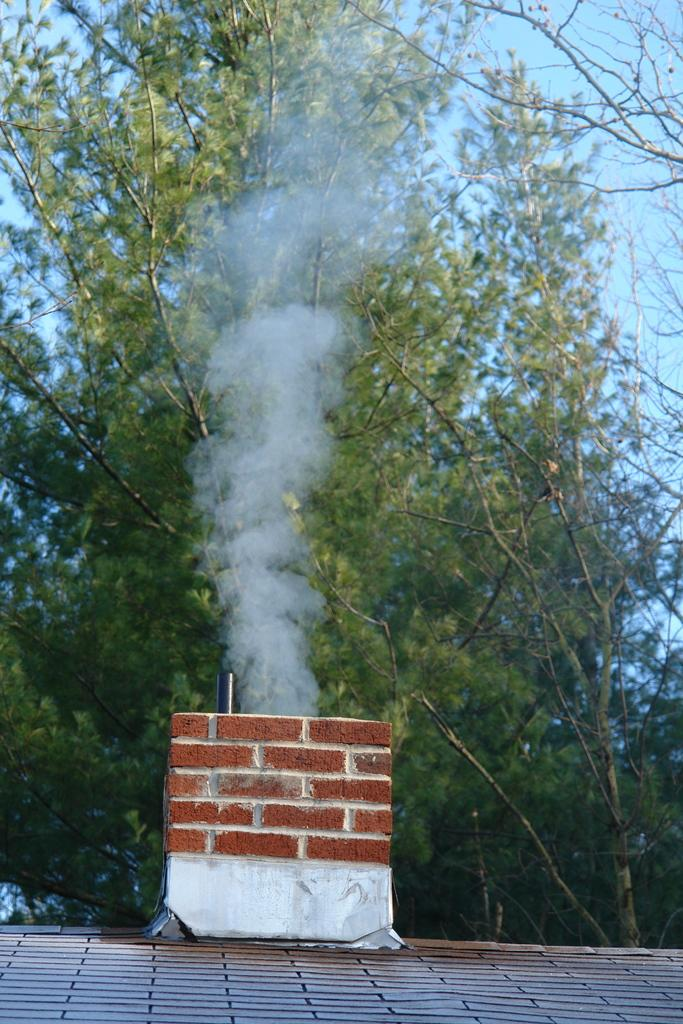What structure can be seen on the roof in the image? There is a rooftop chimney in the image. What is happening with the chimney in the image? Smoke is visible coming from the chimney. What type of vegetation is in the background of the image? There are trees in the background of the image. What part of the natural environment is visible in the background of the image? The sky is visible in the background of the image. Where is the plant located in the image? There is no plant mentioned or visible in the image. What type of camp can be seen in the background of the image? There is no camp present in the image; it features a chimney, trees, and the sky. 